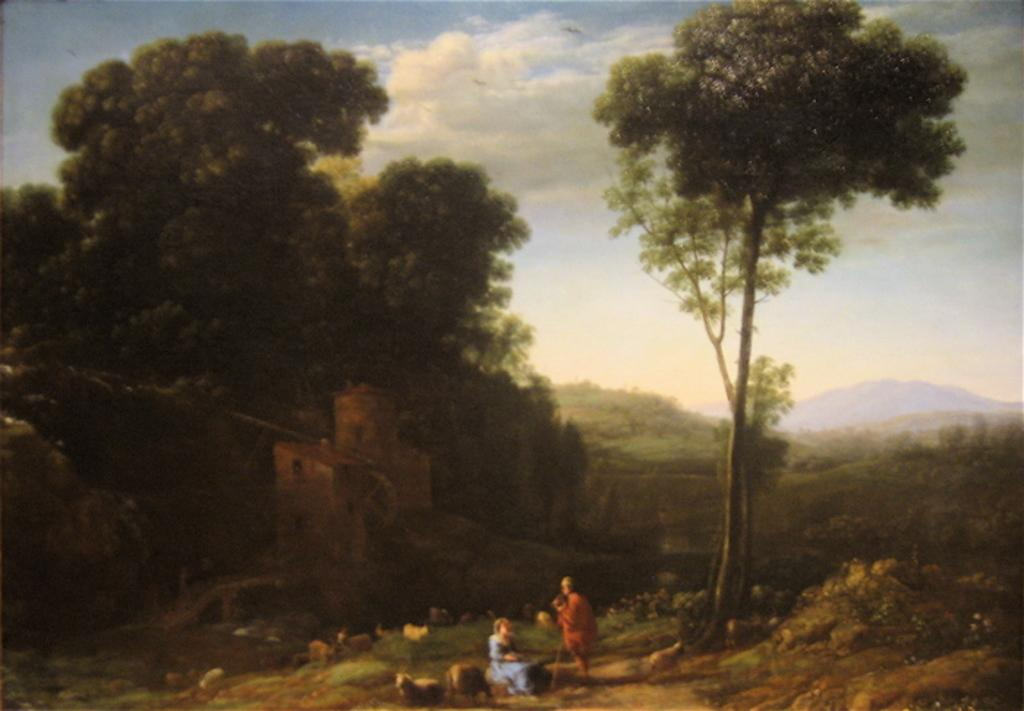What type of natural elements can be seen in the image? There are trees and a hill visible in the image. What part of the sky is visible in the image? The sky is visible in the image. What is the position of the persons and animals in the image? They are in the foreground of the image. How many girls are sitting on the dock in the image? There is no dock or girls present in the image. What type of development can be seen in the background of the image? There is no development visible in the image; it primarily features natural elements. 